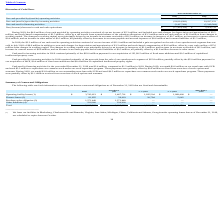According to Luna Innovations Incorporated's financial document, How much outstanding term loan with SVB was repaid during 2018?  According to the financial document, $1.8 million. The relevant text states: "lowances of $3.3 million and a net cash outflow of $1.8 million from changes in working capital. The changes in working capital were principally driven by an increa..." Also, can you calculate: What is the change in Net cash provided by/(used in) operating activities from December 31, 2018 and 2019? Based on the calculation: 4,798,201-(3,308,826), the result is 8107027. This is based on the information: "cash provided by/(used in) operating activities $ 4,798,201 $ (3,308,826) by/(used in) operating activities $ 4,798,201 $ (3,308,826)..." The key data points involved are: 3,308,826, 4,798,201. Also, can you calculate: What is the average Net cash provided by/(used in) operating activities for December 31, 2018 and 2019? To answer this question, I need to perform calculations using the financial data. The calculation is: (4,798,201+(3,308,826)) / 2, which equals 744687.5. This is based on the information: "cash provided by/(used in) operating activities $ 4,798,201 $ (3,308,826) cash provided by/(used in) operating activities $ 4,798,201 $ (3,308,826) by/(used in) operating activities $ 4,798,201 $ (3,3..." The key data points involved are: 2, 3,308,826, 4,798,201. Additionally, In which year was Net cash provided by/(used in) operating activities negative? According to the financial document, 2018. The relevant text states: "2019 2018..." Also, What was the Net cash provided by/(used in) operating activities in 2019 and 2018? The document shows two values: $4,798,201 and $(3,308,826). From the document: "ed by/(used in) operating activities $ 4,798,201 $ (3,308,826) cash provided by/(used in) operating activities $ 4,798,201 $ (3,308,826)..." Also, What was the net increase in cash and cash equivalents in 2018? According to the financial document, $5,478,733. The relevant text states: "ase in cash and cash equivalents $ (17,454,350) $ 5,478,733..." 